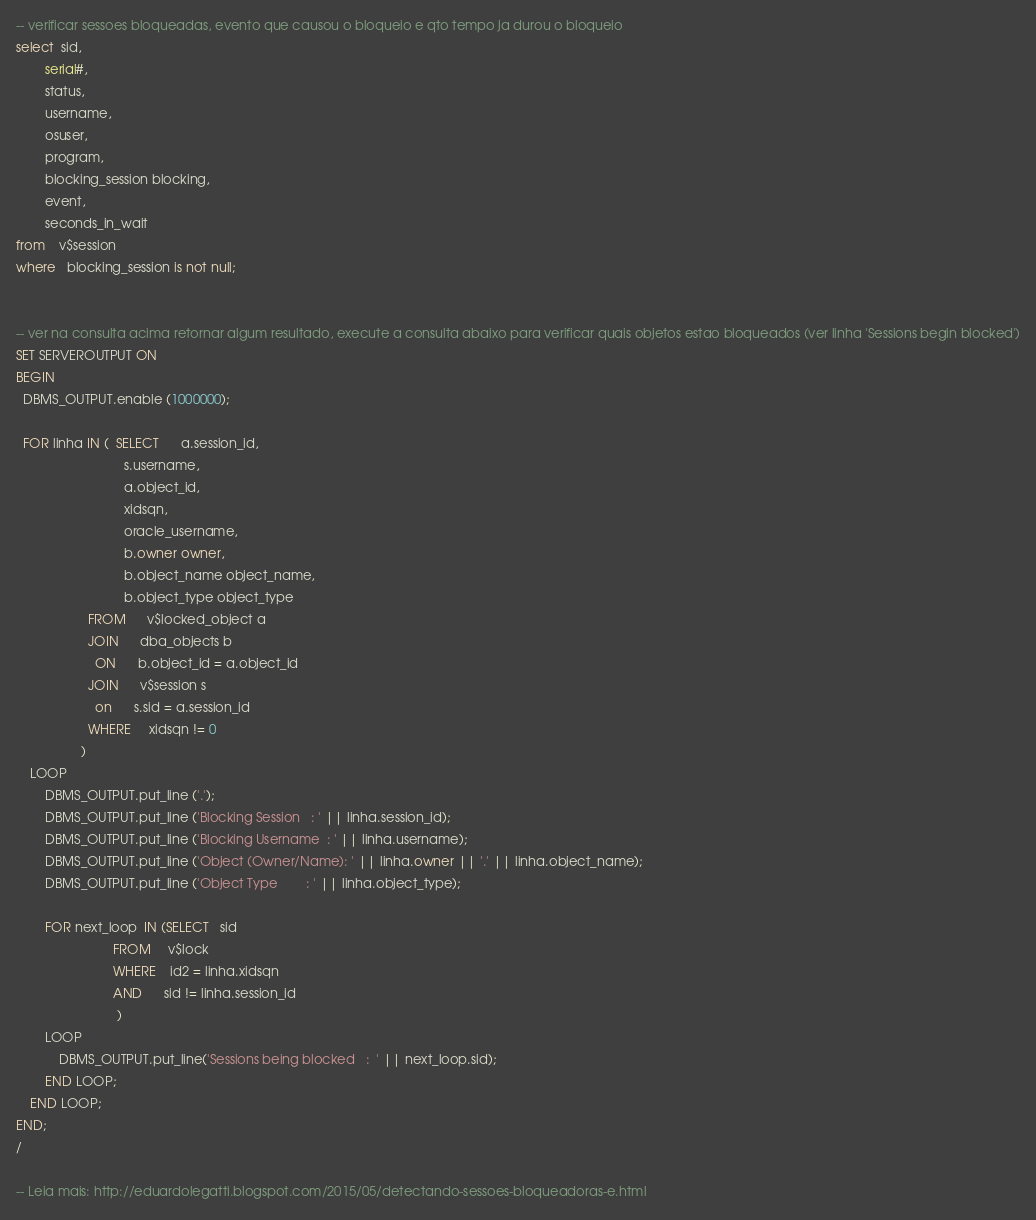Convert code to text. <code><loc_0><loc_0><loc_500><loc_500><_SQL_>-- verificar sessoes bloqueadas, evento que causou o bloqueio e qto tempo ja durou o bloqueio
select  sid, 
        serial#,
        status,
        username,
        osuser,
        program,
        blocking_session blocking,
        event,
        seconds_in_wait
from    v$session
where   blocking_session is not null;


-- ver na consulta acima retornar algum resultado, execute a consulta abaixo para verificar quais objetos estao bloqueados (ver linha 'Sessions begin blocked')
SET SERVEROUTPUT ON
BEGIN
  DBMS_OUTPUT.enable (1000000);
  
  FOR linha IN (  SELECT      a.session_id,
                              s.username,
                              a.object_id,
                              xidsqn,
                              oracle_username,
                              b.owner owner,
                              b.object_name object_name,
                              b.object_type object_type
                    FROM      v$locked_object a
                    JOIN      dba_objects b
                      ON      b.object_id = a.object_id
                    JOIN      v$session s
                      on      s.sid = a.session_id
                    WHERE     xidsqn != 0
                  )
    LOOP
        DBMS_OUTPUT.put_line ('.');
        DBMS_OUTPUT.put_line ('Blocking Session   : ' || linha.session_id);
        DBMS_OUTPUT.put_line ('Blocking Username  : ' || linha.username);
        DBMS_OUTPUT.put_line ('Object (Owner/Name): ' || linha.owner || '.' || linha.object_name); 
        DBMS_OUTPUT.put_line ('Object Type        : ' || linha.object_type);
      
        FOR next_loop  IN (SELECT   sid
                           FROM     v$lock
                           WHERE    id2 = linha.xidsqn
                           AND      sid != linha.session_id
                            )
        LOOP
            DBMS_OUTPUT.put_line('Sessions being blocked   :  ' || next_loop.sid);
        END LOOP;
    END LOOP;
END;
/

-- Leia mais: http://eduardolegatti.blogspot.com/2015/05/detectando-sessoes-bloqueadoras-e.html</code> 